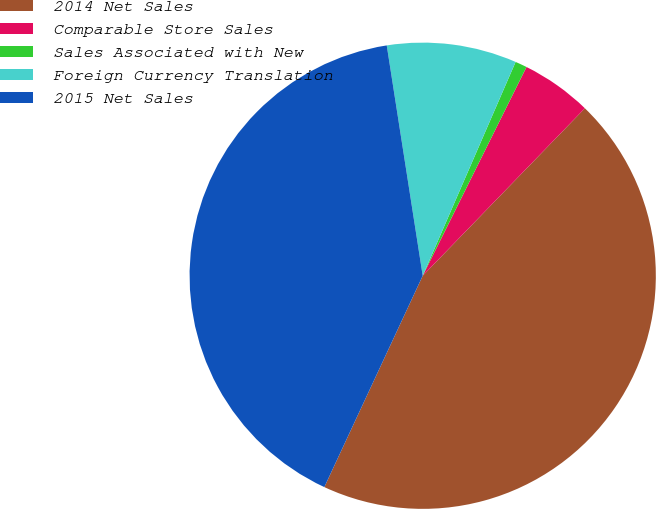Convert chart to OTSL. <chart><loc_0><loc_0><loc_500><loc_500><pie_chart><fcel>2014 Net Sales<fcel>Comparable Store Sales<fcel>Sales Associated with New<fcel>Foreign Currency Translation<fcel>2015 Net Sales<nl><fcel>44.69%<fcel>4.9%<fcel>0.82%<fcel>8.99%<fcel>40.6%<nl></chart> 